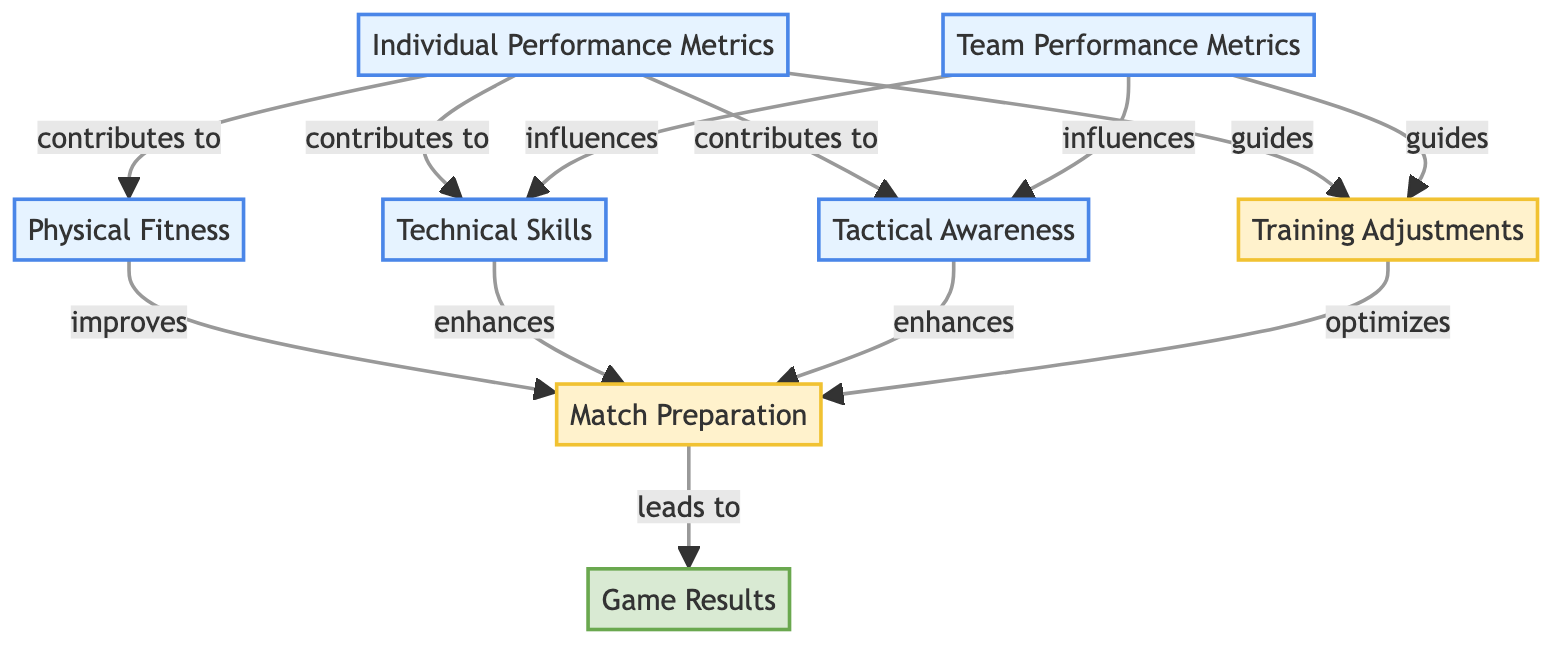What are the two individual metrics that contribute to technical skills? In the diagram, the edges point from "Individual Performance Metrics" to both "Technical Skills" and "Physical Fitness". Since the question asks for contributions specifically to "Technical Skills", we only consider "Individual Performance Metrics" as the source. The two contributing edges to "Technical Skills" show that "Physical Fitness" and "Tactical Awareness" also contribute to individual performance metrics. Therefore, they are the two individual metrics listed.
Answer: Physical fitness, tactical awareness How many nodes are there in the directed graph? The graph features a total of eight nodes: "Individual Performance Metrics", "Team Performance Metrics", "Physical Fitness", "Technical Skills", "Tactical Awareness", "Training Adjustments", "Match Preparation", and "Game Results". Counting them gives us a total of eight.
Answer: 8 What does "Training Adjustments" optimize? Analyzing the directed edges leading from "Training Adjustments" to "Match Preparation", we see that this process is linked with optimizing the process of getting a team ready for matches. No other nodes are influenced directly by "Training Adjustments", confirming it specifically optimizes "Match Preparation".
Answer: Match preparation Which individual metrics guide training adjustments? The directed edges show that both "Individual Performance Metrics" and "Team Performance Metrics" contribute to the process of "Training Adjustments". This means that both these metrics actively guide how training adjustments are made, as represented by the arrows leading into this process node.
Answer: Individual performance metrics, team performance metrics What leads to game results? The diagram outlines that the process "Match Preparation" leads to the outcome "Game Results". There are no other direct connections to "Game Results" other than from "Match Preparation", confirming this relationship as the single pathway leading to the final outcome.
Answer: Match preparation 